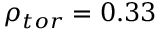<formula> <loc_0><loc_0><loc_500><loc_500>\rho _ { t o r } = 0 . 3 3</formula> 